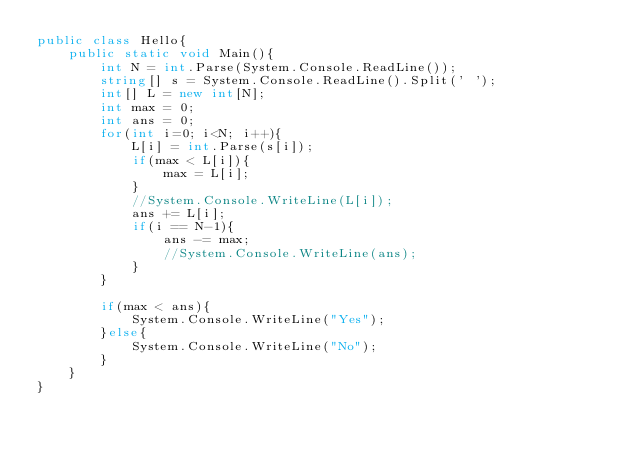<code> <loc_0><loc_0><loc_500><loc_500><_C#_>public class Hello{
    public static void Main(){
        int N = int.Parse(System.Console.ReadLine());
        string[] s = System.Console.ReadLine().Split(' ');
        int[] L = new int[N];
        int max = 0;
        int ans = 0;
        for(int i=0; i<N; i++){
            L[i] = int.Parse(s[i]);
            if(max < L[i]){
                max = L[i];
            }
            //System.Console.WriteLine(L[i]);
            ans += L[i];
            if(i == N-1){
                ans -= max;
                //System.Console.WriteLine(ans);
            }
        }
        
        if(max < ans){
            System.Console.WriteLine("Yes");
        }else{
            System.Console.WriteLine("No");
        }    
    }
}</code> 